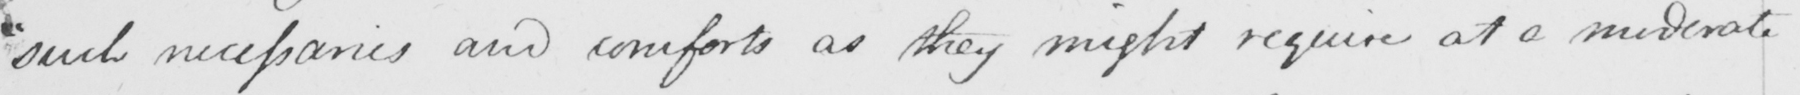Can you read and transcribe this handwriting? " such necessaries and comforts as they might require at a moderate 